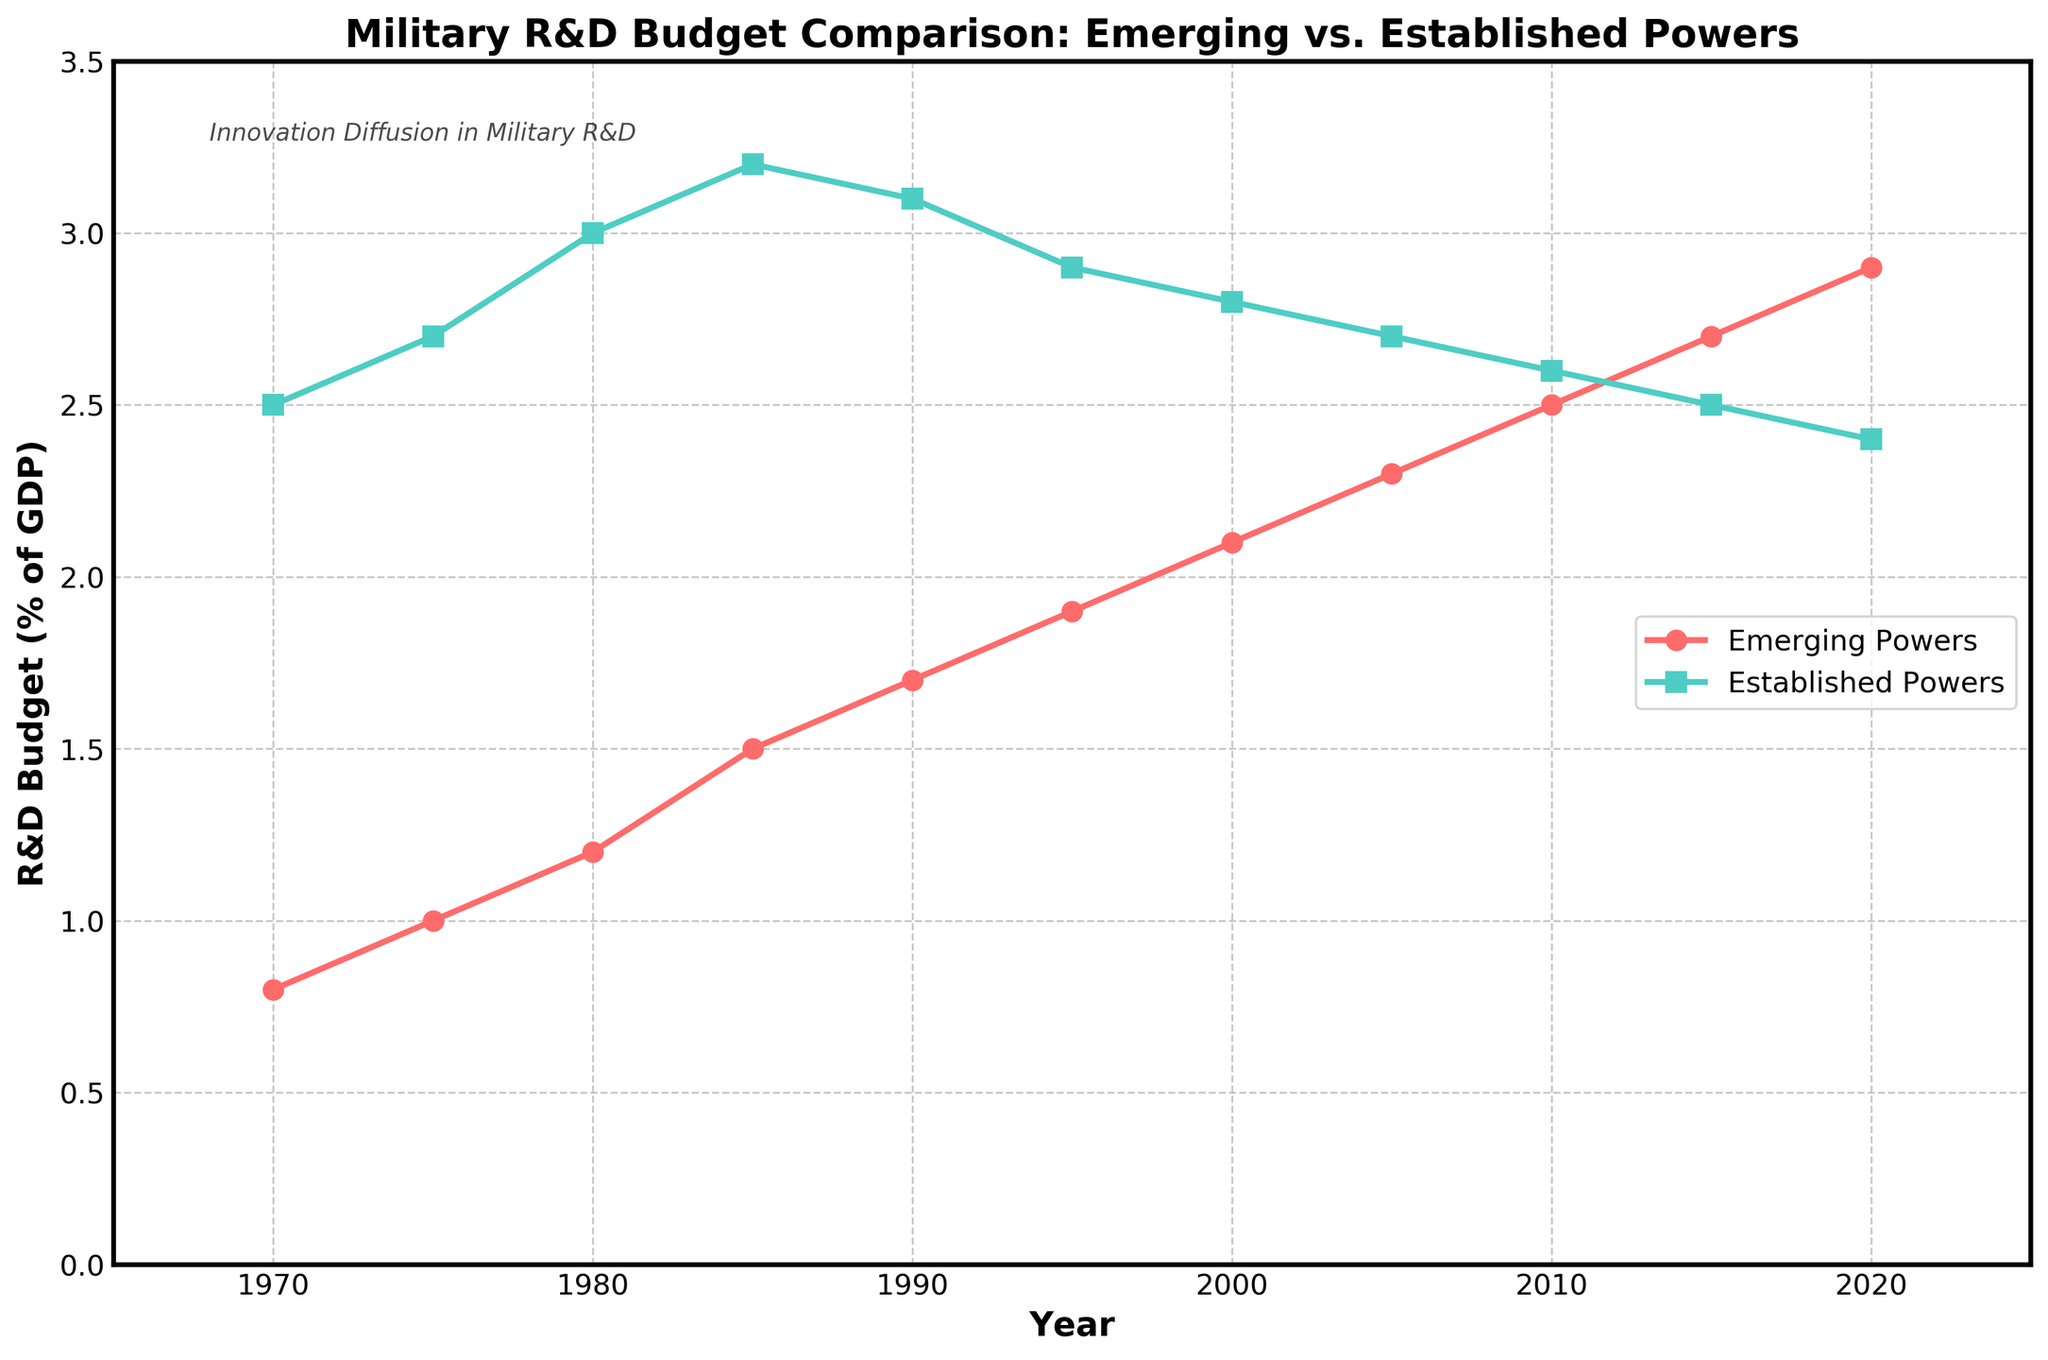What's the year when Emerging Powers' R&D budget first surpassed 2% of GDP? We identify the data points for Emerging Powers and focus on the years when R&D budget is first above 2%. According to the figure, Emerging Powers' budget surpasses 2% of GDP in the year 2000.
Answer: 2000 At what year are the R&D budgets of Emerging and Established Powers closest to each other? We look at the points where the lines representing the R&D budgets of Emerging and Established Powers nearly intersect. The year with the smallest difference visually is 2020.
Answer: 2020 How does the R&D budget (% of GDP) for Emerging Powers in 1980 compare to that for Established Powers in 2020? In 1980, the R&D budget for Emerging Powers is approximately 1.2% of GDP and for Established Powers in 2020 it is approximately 2.4% of GDP. Therefore, the R&D budget of Emerging Powers in 1980 is lower.
Answer: Lower What is the average R&D budget for Emerging Powers between 2000 and 2020? We calculate the average by summing the percentages for Emerging Powers during these years and dividing by the number of data points (5). The values are 2.1, 2.3, 2.5, 2.7, and 2.9. The sum is 12.5, and dividing by 5 gives the average.
Answer: 2.5 Which year shows a decrease in the R&D budget for Established Powers compared to the previous period? By inspecting the line representing Established Powers' R&D budget, we see it decreases from 1985 (3.2%) to 1990 (3.1%), and again from 2015 (2.5%) to 2020 (2.4%).
Answer: 1990, 2020 What is the total increase in R&D budget for Emerging Powers from 1970 to 2020? We compute the difference between the R&D budget in 2020 (2.9%) and in 1970 (0.8%). Subtract 0.8 from 2.9 which gives 2.1%.
Answer: 2.1% How do the R&D budget trends for Emerging Powers and Established Powers compare over the last 50 years? The Emerging Powers' R&D budget steadily increases from 0.8% in 1970 to 2.9% in 2020, while the Established Powers’ budget increases from 2.5% in 1970 to a peak of 3.2% in 1985, then decreases to 2.4% in 2020. The Emerging Powers show a steady rise while Established Powers initially grow but then decline.
Answer: Emerging Powers show a steady rise; Established Powers show initial growth then decline What visual feature distinguishes the lines representing Emerging Powers and Established Powers? The line representing Emerging Powers is depicted with circles (o) as data points and is colored red, while the line for Established Powers is depicted with squares (s) and is colored green.
Answer: Marker shapes and colors Between 1995 and 2005, which power group shows a greater absolute increase in their R&D budget? For Emerging Powers, from 1995 (1.9%) to 2005 (2.3%) the increase is 0.4%. For Established Powers, from 1995 (2.9%) to 2005 (2.7%) there is a decrease by 0.2%. Therefore, Emerging Powers show a greater absolute increase.
Answer: Emerging Powers 